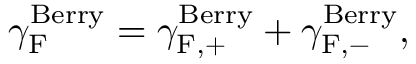Convert formula to latex. <formula><loc_0><loc_0><loc_500><loc_500>{ \gamma } _ { F } ^ { B e r r y } = { \gamma } _ { F , + } ^ { B e r r y } + { \gamma } _ { F , - } ^ { B e r r y } ,</formula> 